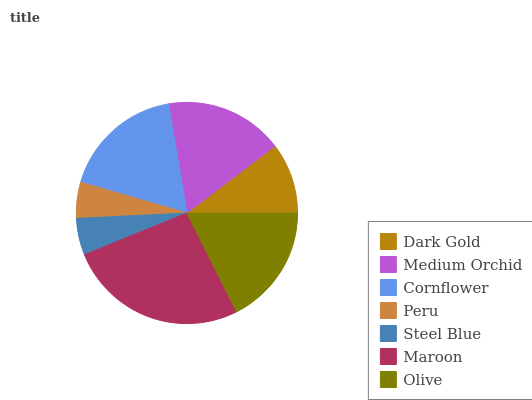Is Peru the minimum?
Answer yes or no. Yes. Is Maroon the maximum?
Answer yes or no. Yes. Is Medium Orchid the minimum?
Answer yes or no. No. Is Medium Orchid the maximum?
Answer yes or no. No. Is Medium Orchid greater than Dark Gold?
Answer yes or no. Yes. Is Dark Gold less than Medium Orchid?
Answer yes or no. Yes. Is Dark Gold greater than Medium Orchid?
Answer yes or no. No. Is Medium Orchid less than Dark Gold?
Answer yes or no. No. Is Medium Orchid the high median?
Answer yes or no. Yes. Is Medium Orchid the low median?
Answer yes or no. Yes. Is Olive the high median?
Answer yes or no. No. Is Maroon the low median?
Answer yes or no. No. 